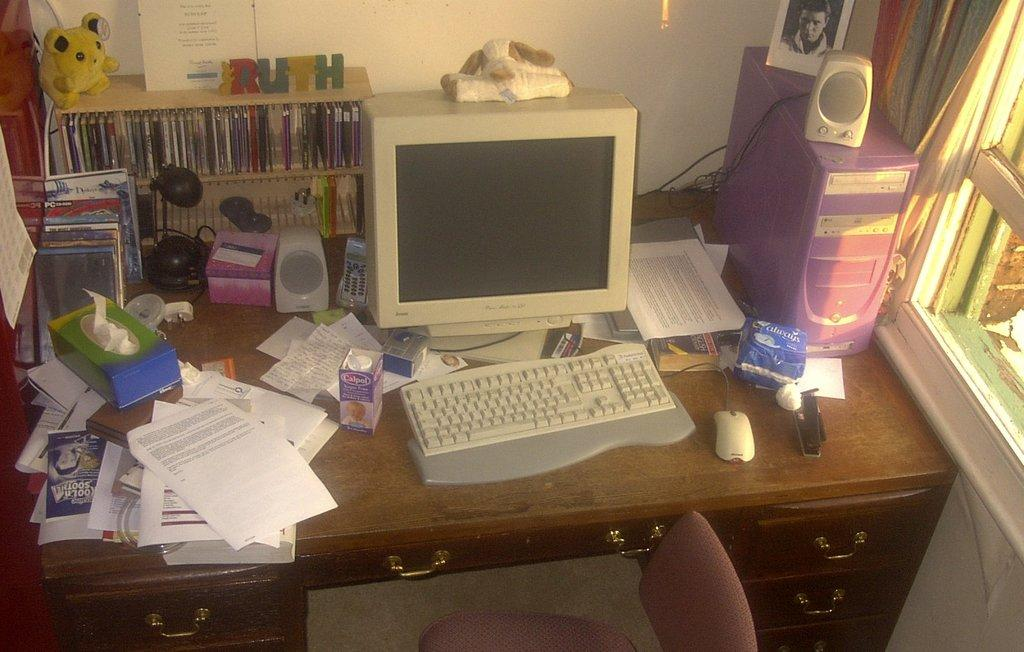What is the main object in the center of the image? There is a table in the center of the image. What electronic devices are on the table? A monitor, keyboard, mouse, and PC are on the table. What other items can be seen on the table? A tetra pack, papers, a box, a shelf, and a doll are on the table. What type of seating is visible in the image? There is a chair in the bottom of the image. What can be seen in the background of the image? A wall and a window are present in the background. How many plastic items can be seen hanging from the string in the image? There is no plastic or string present in the image. 